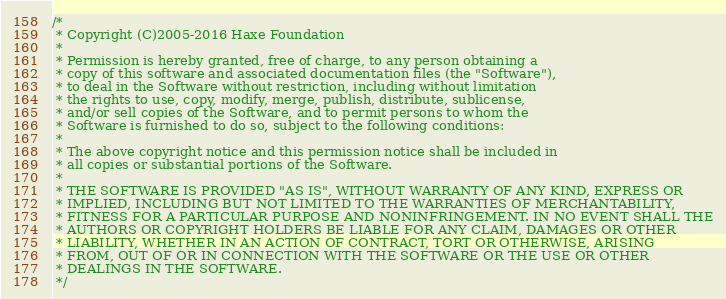<code> <loc_0><loc_0><loc_500><loc_500><_Haxe_>/*
 * Copyright (C)2005-2016 Haxe Foundation
 *
 * Permission is hereby granted, free of charge, to any person obtaining a
 * copy of this software and associated documentation files (the "Software"),
 * to deal in the Software without restriction, including without limitation
 * the rights to use, copy, modify, merge, publish, distribute, sublicense,
 * and/or sell copies of the Software, and to permit persons to whom the
 * Software is furnished to do so, subject to the following conditions:
 *
 * The above copyright notice and this permission notice shall be included in
 * all copies or substantial portions of the Software.
 *
 * THE SOFTWARE IS PROVIDED "AS IS", WITHOUT WARRANTY OF ANY KIND, EXPRESS OR
 * IMPLIED, INCLUDING BUT NOT LIMITED TO THE WARRANTIES OF MERCHANTABILITY,
 * FITNESS FOR A PARTICULAR PURPOSE AND NONINFRINGEMENT. IN NO EVENT SHALL THE
 * AUTHORS OR COPYRIGHT HOLDERS BE LIABLE FOR ANY CLAIM, DAMAGES OR OTHER
 * LIABILITY, WHETHER IN AN ACTION OF CONTRACT, TORT OR OTHERWISE, ARISING
 * FROM, OUT OF OR IN CONNECTION WITH THE SOFTWARE OR THE USE OR OTHER
 * DEALINGS IN THE SOFTWARE.
 */
</code> 